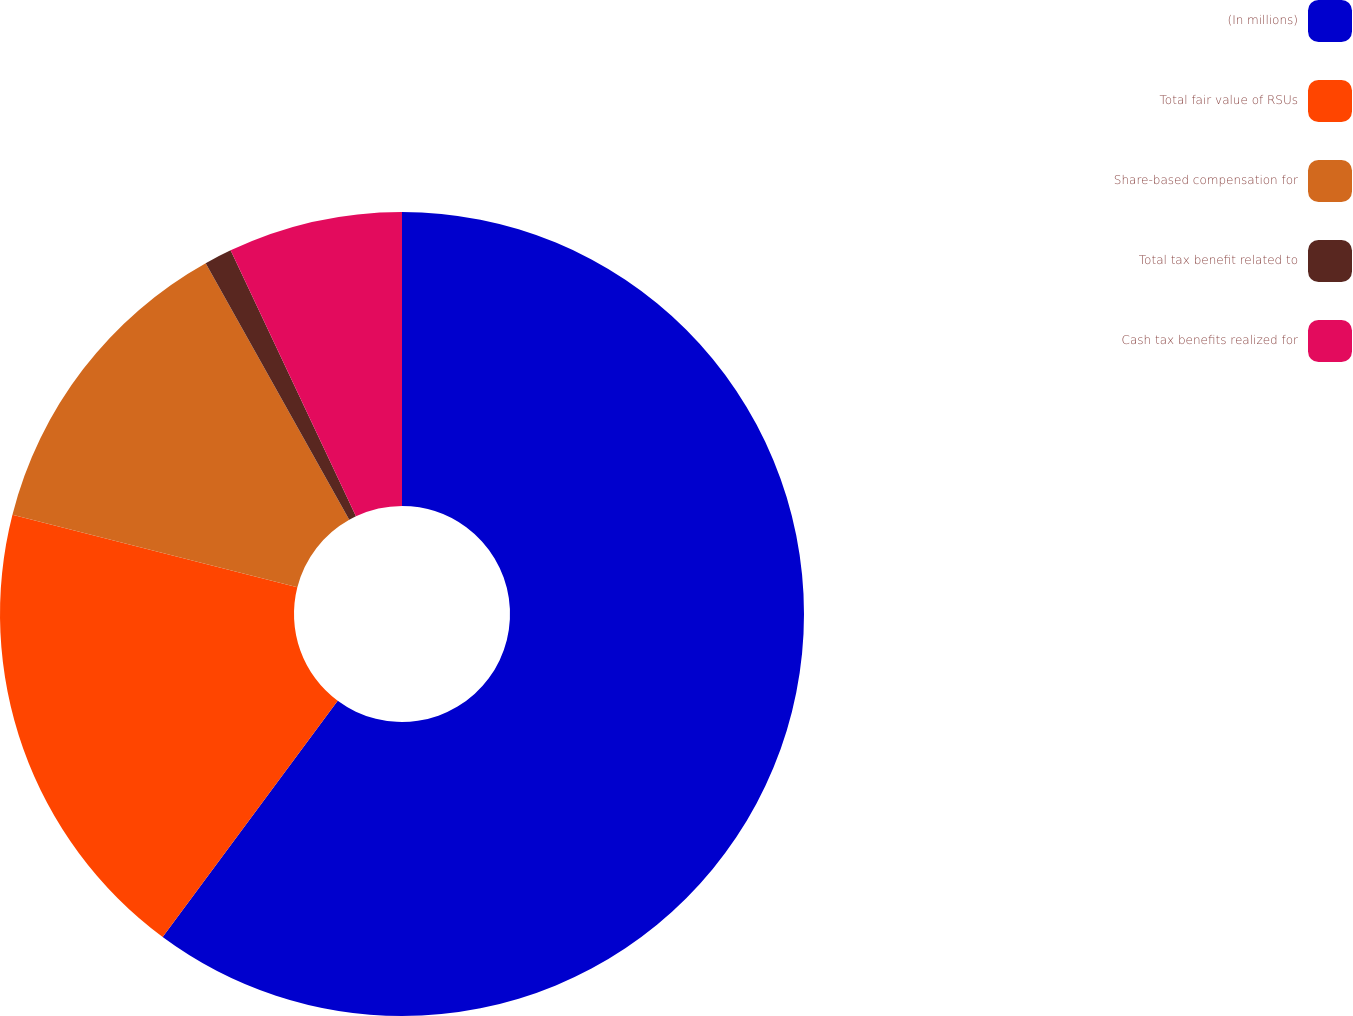Convert chart to OTSL. <chart><loc_0><loc_0><loc_500><loc_500><pie_chart><fcel>(In millions)<fcel>Total fair value of RSUs<fcel>Share-based compensation for<fcel>Total tax benefit related to<fcel>Cash tax benefits realized for<nl><fcel>60.15%<fcel>18.82%<fcel>12.91%<fcel>1.11%<fcel>7.01%<nl></chart> 